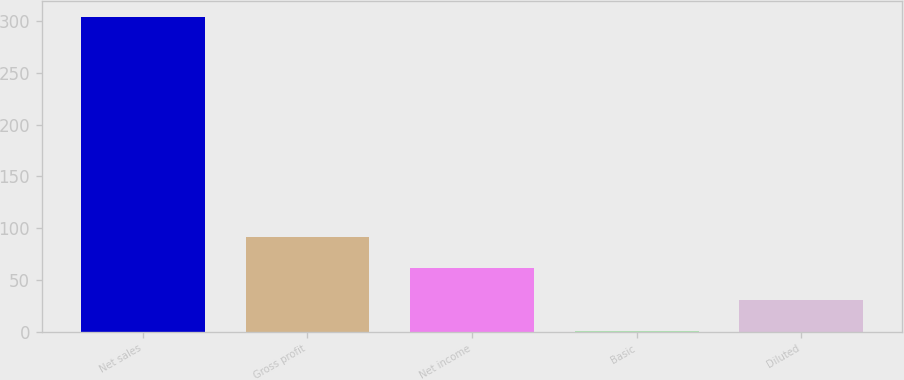Convert chart. <chart><loc_0><loc_0><loc_500><loc_500><bar_chart><fcel>Net sales<fcel>Gross profit<fcel>Net income<fcel>Basic<fcel>Diluted<nl><fcel>303.8<fcel>91.45<fcel>61.11<fcel>0.43<fcel>30.77<nl></chart> 